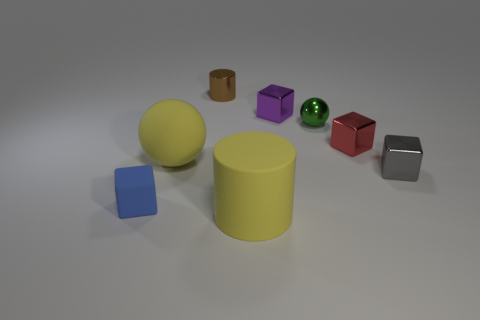Add 1 tiny purple objects. How many objects exist? 9 Subtract all cylinders. How many objects are left? 6 Subtract 0 brown spheres. How many objects are left? 8 Subtract all large red objects. Subtract all big rubber cylinders. How many objects are left? 7 Add 8 blue matte blocks. How many blue matte blocks are left? 9 Add 3 large purple matte balls. How many large purple matte balls exist? 3 